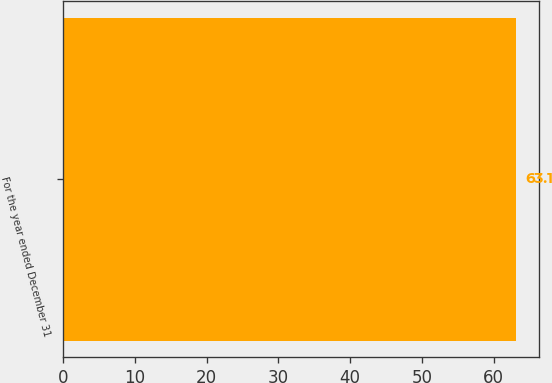Convert chart. <chart><loc_0><loc_0><loc_500><loc_500><bar_chart><fcel>For the year ended December 31<nl><fcel>63.1<nl></chart> 